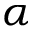<formula> <loc_0><loc_0><loc_500><loc_500>\alpha</formula> 